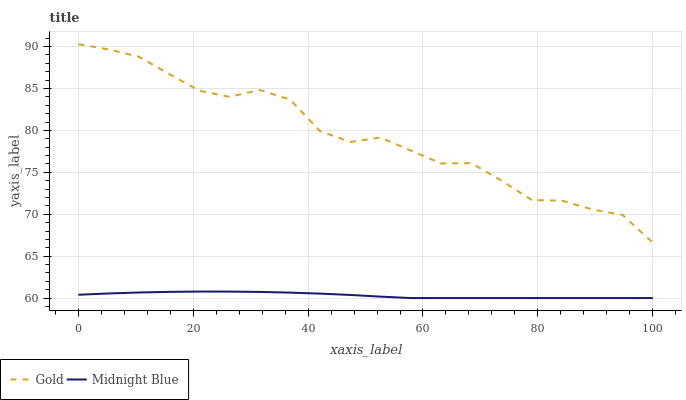Does Midnight Blue have the minimum area under the curve?
Answer yes or no. Yes. Does Gold have the maximum area under the curve?
Answer yes or no. Yes. Does Gold have the minimum area under the curve?
Answer yes or no. No. Is Midnight Blue the smoothest?
Answer yes or no. Yes. Is Gold the roughest?
Answer yes or no. Yes. Is Gold the smoothest?
Answer yes or no. No. Does Midnight Blue have the lowest value?
Answer yes or no. Yes. Does Gold have the lowest value?
Answer yes or no. No. Does Gold have the highest value?
Answer yes or no. Yes. Is Midnight Blue less than Gold?
Answer yes or no. Yes. Is Gold greater than Midnight Blue?
Answer yes or no. Yes. Does Midnight Blue intersect Gold?
Answer yes or no. No. 